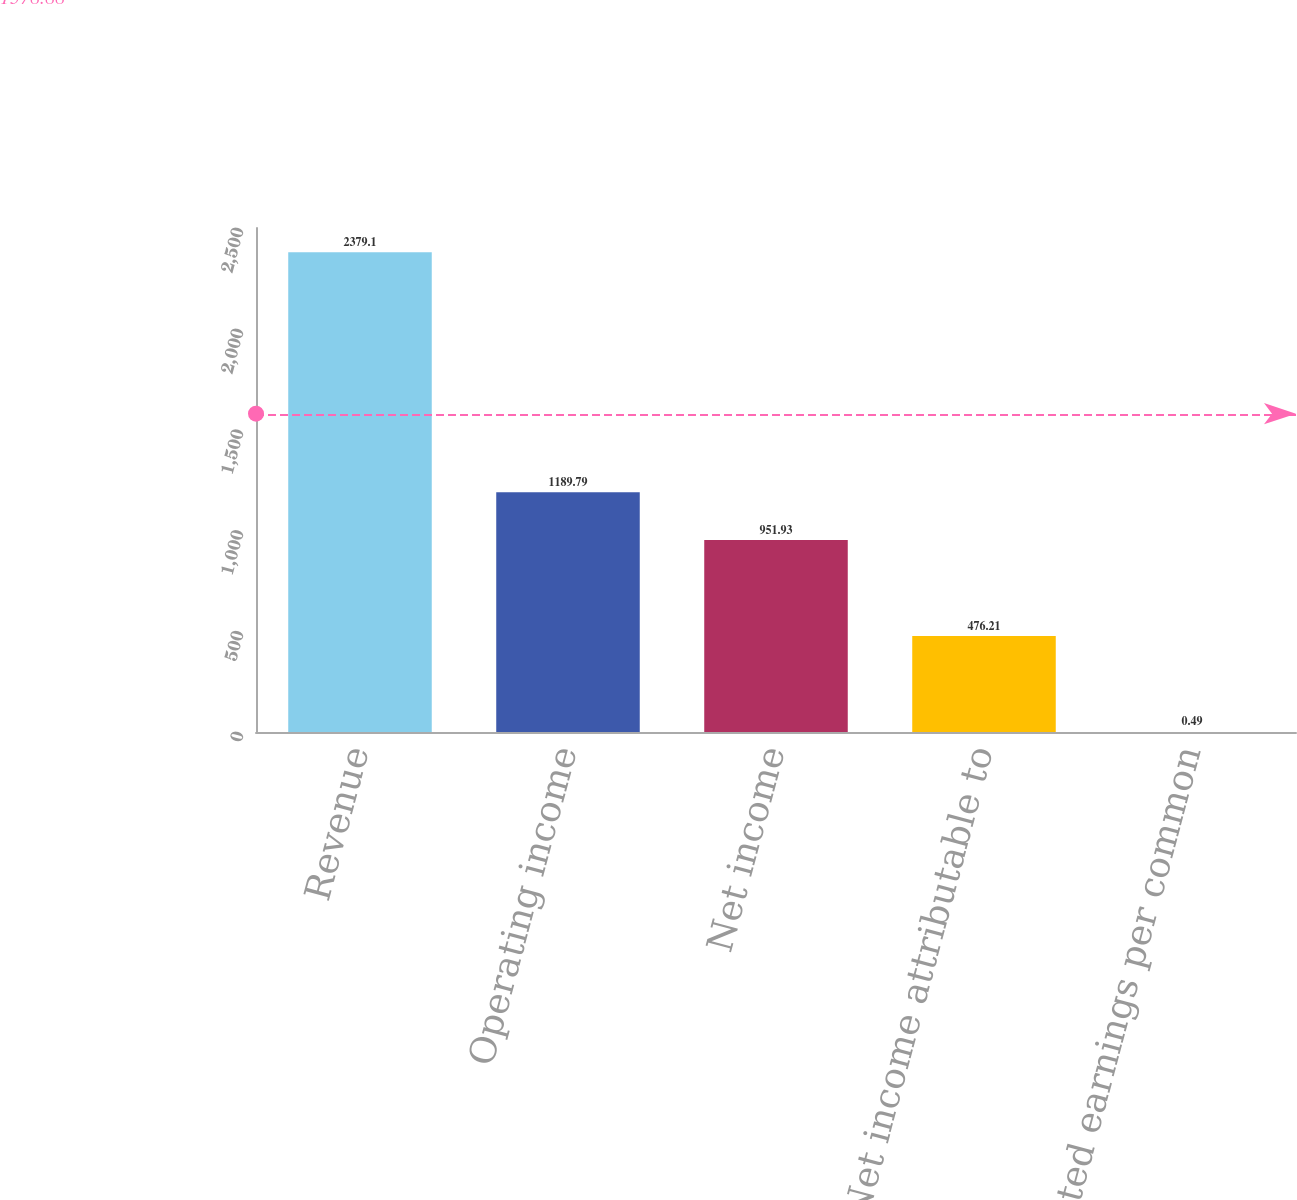Convert chart to OTSL. <chart><loc_0><loc_0><loc_500><loc_500><bar_chart><fcel>Revenue<fcel>Operating income<fcel>Net income<fcel>Net income attributable to<fcel>Diluted earnings per common<nl><fcel>2379.1<fcel>1189.79<fcel>951.93<fcel>476.21<fcel>0.49<nl></chart> 